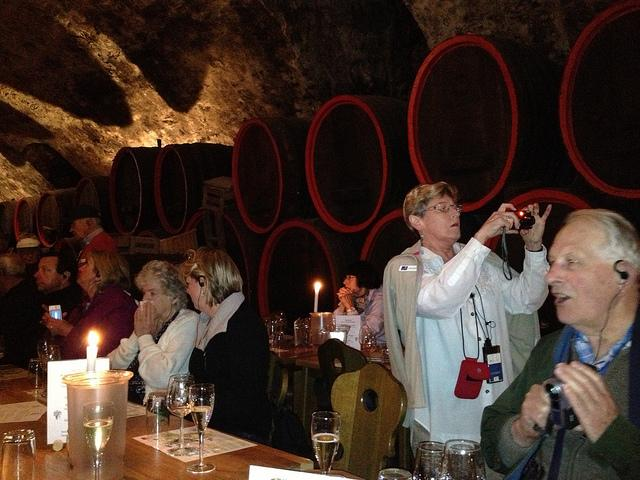What would most likely be stored in this type of location? Please explain your reasoning. alcohol. In order to age the alcohol it's stored in barrels. 